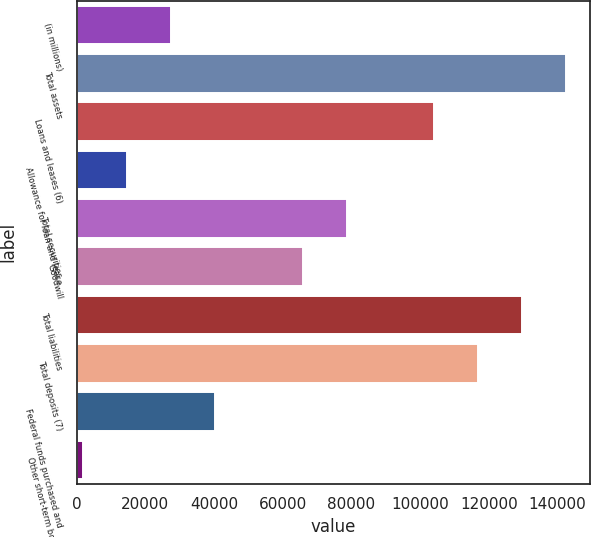Convert chart to OTSL. <chart><loc_0><loc_0><loc_500><loc_500><bar_chart><fcel>(in millions)<fcel>Total assets<fcel>Loans and leases (6)<fcel>Allowance for loan and lease<fcel>Total securities<fcel>Goodwill<fcel>Total liabilities<fcel>Total deposits (7)<fcel>Federal funds purchased and<fcel>Other short-term borrowed<nl><fcel>27481.8<fcel>142465<fcel>104137<fcel>14705.9<fcel>78585.4<fcel>65809.5<fcel>129689<fcel>116913<fcel>40257.7<fcel>1930<nl></chart> 